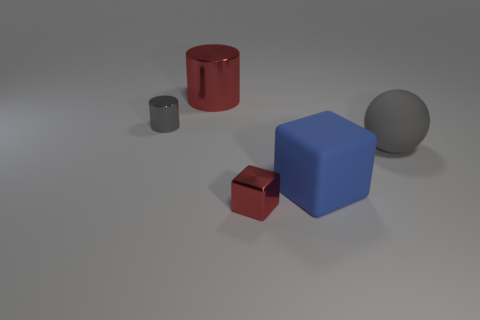Subtract all cyan cylinders. Subtract all purple spheres. How many cylinders are left? 2 Add 1 large red things. How many objects exist? 6 Subtract all cylinders. How many objects are left? 3 Add 1 tiny objects. How many tiny objects exist? 3 Subtract 0 brown spheres. How many objects are left? 5 Subtract all red blocks. Subtract all gray matte balls. How many objects are left? 3 Add 3 large gray rubber spheres. How many large gray rubber spheres are left? 4 